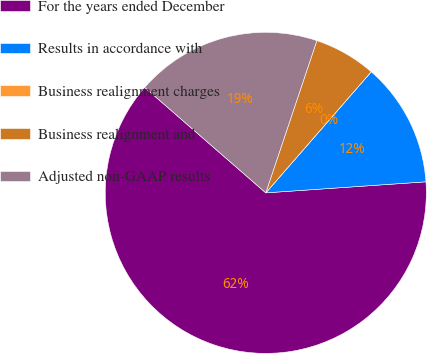<chart> <loc_0><loc_0><loc_500><loc_500><pie_chart><fcel>For the years ended December<fcel>Results in accordance with<fcel>Business realignment charges<fcel>Business realignment and<fcel>Adjusted non-GAAP results<nl><fcel>62.5%<fcel>12.5%<fcel>0.0%<fcel>6.25%<fcel>18.75%<nl></chart> 